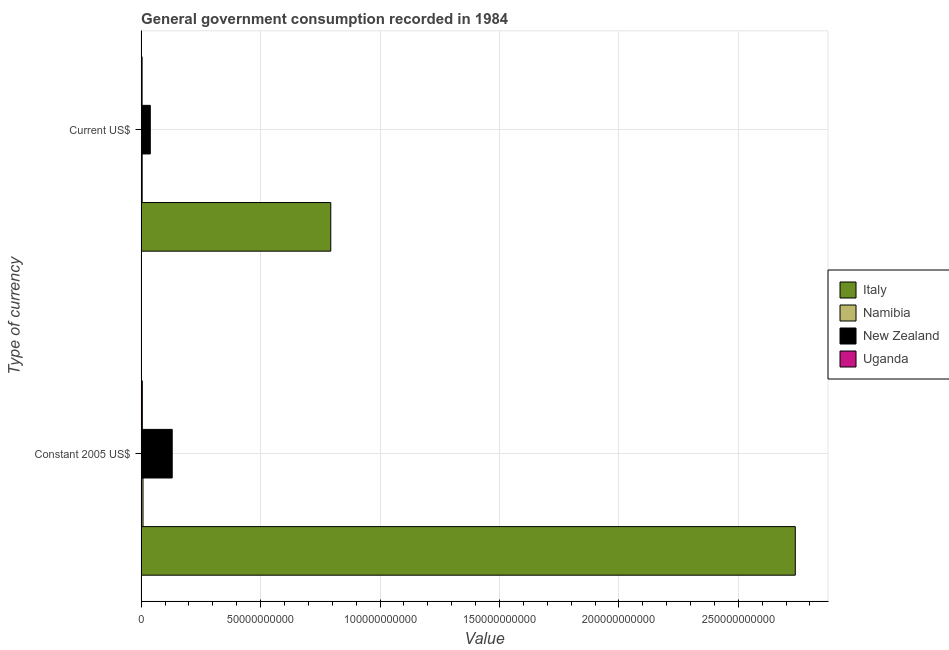How many different coloured bars are there?
Provide a short and direct response. 4. How many groups of bars are there?
Your response must be concise. 2. Are the number of bars per tick equal to the number of legend labels?
Provide a short and direct response. Yes. How many bars are there on the 1st tick from the bottom?
Offer a very short reply. 4. What is the label of the 1st group of bars from the top?
Provide a succinct answer. Current US$. What is the value consumed in current us$ in Namibia?
Give a very brief answer. 4.35e+08. Across all countries, what is the maximum value consumed in constant 2005 us$?
Ensure brevity in your answer.  2.74e+11. Across all countries, what is the minimum value consumed in current us$?
Provide a short and direct response. 3.97e+08. In which country was the value consumed in current us$ minimum?
Offer a very short reply. Uganda. What is the total value consumed in current us$ in the graph?
Provide a succinct answer. 8.40e+1. What is the difference between the value consumed in current us$ in Namibia and that in New Zealand?
Provide a succinct answer. -3.39e+09. What is the difference between the value consumed in constant 2005 us$ in Namibia and the value consumed in current us$ in Uganda?
Give a very brief answer. 3.85e+08. What is the average value consumed in constant 2005 us$ per country?
Offer a very short reply. 7.20e+1. What is the difference between the value consumed in constant 2005 us$ and value consumed in current us$ in Uganda?
Keep it short and to the point. 9.58e+07. What is the ratio of the value consumed in current us$ in New Zealand to that in Namibia?
Offer a very short reply. 8.79. Is the value consumed in current us$ in Uganda less than that in Italy?
Ensure brevity in your answer.  Yes. What does the 4th bar from the top in Current US$ represents?
Provide a succinct answer. Italy. How many bars are there?
Your answer should be compact. 8. What is the difference between two consecutive major ticks on the X-axis?
Ensure brevity in your answer.  5.00e+1. Where does the legend appear in the graph?
Offer a very short reply. Center right. How many legend labels are there?
Offer a terse response. 4. How are the legend labels stacked?
Your answer should be compact. Vertical. What is the title of the graph?
Your answer should be compact. General government consumption recorded in 1984. What is the label or title of the X-axis?
Your answer should be compact. Value. What is the label or title of the Y-axis?
Provide a short and direct response. Type of currency. What is the Value of Italy in Constant 2005 US$?
Your answer should be compact. 2.74e+11. What is the Value of Namibia in Constant 2005 US$?
Make the answer very short. 7.82e+08. What is the Value of New Zealand in Constant 2005 US$?
Keep it short and to the point. 1.30e+1. What is the Value of Uganda in Constant 2005 US$?
Make the answer very short. 4.93e+08. What is the Value in Italy in Current US$?
Ensure brevity in your answer.  7.94e+1. What is the Value of Namibia in Current US$?
Ensure brevity in your answer.  4.35e+08. What is the Value of New Zealand in Current US$?
Ensure brevity in your answer.  3.83e+09. What is the Value in Uganda in Current US$?
Give a very brief answer. 3.97e+08. Across all Type of currency, what is the maximum Value of Italy?
Your response must be concise. 2.74e+11. Across all Type of currency, what is the maximum Value of Namibia?
Ensure brevity in your answer.  7.82e+08. Across all Type of currency, what is the maximum Value in New Zealand?
Your response must be concise. 1.30e+1. Across all Type of currency, what is the maximum Value in Uganda?
Your answer should be very brief. 4.93e+08. Across all Type of currency, what is the minimum Value of Italy?
Your answer should be very brief. 7.94e+1. Across all Type of currency, what is the minimum Value of Namibia?
Provide a short and direct response. 4.35e+08. Across all Type of currency, what is the minimum Value of New Zealand?
Ensure brevity in your answer.  3.83e+09. Across all Type of currency, what is the minimum Value of Uganda?
Make the answer very short. 3.97e+08. What is the total Value in Italy in the graph?
Make the answer very short. 3.53e+11. What is the total Value in Namibia in the graph?
Provide a short and direct response. 1.22e+09. What is the total Value in New Zealand in the graph?
Your answer should be compact. 1.68e+1. What is the total Value in Uganda in the graph?
Offer a terse response. 8.90e+08. What is the difference between the Value of Italy in Constant 2005 US$ and that in Current US$?
Your response must be concise. 1.94e+11. What is the difference between the Value of Namibia in Constant 2005 US$ and that in Current US$?
Make the answer very short. 3.46e+08. What is the difference between the Value in New Zealand in Constant 2005 US$ and that in Current US$?
Provide a succinct answer. 9.18e+09. What is the difference between the Value in Uganda in Constant 2005 US$ and that in Current US$?
Give a very brief answer. 9.58e+07. What is the difference between the Value of Italy in Constant 2005 US$ and the Value of Namibia in Current US$?
Make the answer very short. 2.73e+11. What is the difference between the Value in Italy in Constant 2005 US$ and the Value in New Zealand in Current US$?
Ensure brevity in your answer.  2.70e+11. What is the difference between the Value in Italy in Constant 2005 US$ and the Value in Uganda in Current US$?
Provide a succinct answer. 2.73e+11. What is the difference between the Value in Namibia in Constant 2005 US$ and the Value in New Zealand in Current US$?
Your answer should be compact. -3.05e+09. What is the difference between the Value of Namibia in Constant 2005 US$ and the Value of Uganda in Current US$?
Offer a very short reply. 3.85e+08. What is the difference between the Value in New Zealand in Constant 2005 US$ and the Value in Uganda in Current US$?
Your answer should be compact. 1.26e+1. What is the average Value in Italy per Type of currency?
Ensure brevity in your answer.  1.77e+11. What is the average Value of Namibia per Type of currency?
Provide a short and direct response. 6.08e+08. What is the average Value in New Zealand per Type of currency?
Offer a terse response. 8.42e+09. What is the average Value of Uganda per Type of currency?
Keep it short and to the point. 4.45e+08. What is the difference between the Value of Italy and Value of Namibia in Constant 2005 US$?
Offer a terse response. 2.73e+11. What is the difference between the Value of Italy and Value of New Zealand in Constant 2005 US$?
Keep it short and to the point. 2.61e+11. What is the difference between the Value of Italy and Value of Uganda in Constant 2005 US$?
Provide a short and direct response. 2.73e+11. What is the difference between the Value of Namibia and Value of New Zealand in Constant 2005 US$?
Keep it short and to the point. -1.22e+1. What is the difference between the Value in Namibia and Value in Uganda in Constant 2005 US$?
Ensure brevity in your answer.  2.89e+08. What is the difference between the Value of New Zealand and Value of Uganda in Constant 2005 US$?
Make the answer very short. 1.25e+1. What is the difference between the Value of Italy and Value of Namibia in Current US$?
Give a very brief answer. 7.89e+1. What is the difference between the Value in Italy and Value in New Zealand in Current US$?
Offer a terse response. 7.56e+1. What is the difference between the Value of Italy and Value of Uganda in Current US$?
Your answer should be very brief. 7.90e+1. What is the difference between the Value in Namibia and Value in New Zealand in Current US$?
Your response must be concise. -3.39e+09. What is the difference between the Value in Namibia and Value in Uganda in Current US$?
Keep it short and to the point. 3.85e+07. What is the difference between the Value of New Zealand and Value of Uganda in Current US$?
Give a very brief answer. 3.43e+09. What is the ratio of the Value of Italy in Constant 2005 US$ to that in Current US$?
Ensure brevity in your answer.  3.45. What is the ratio of the Value in Namibia in Constant 2005 US$ to that in Current US$?
Your answer should be compact. 1.8. What is the ratio of the Value in New Zealand in Constant 2005 US$ to that in Current US$?
Provide a succinct answer. 3.4. What is the ratio of the Value in Uganda in Constant 2005 US$ to that in Current US$?
Provide a succinct answer. 1.24. What is the difference between the highest and the second highest Value of Italy?
Your answer should be very brief. 1.94e+11. What is the difference between the highest and the second highest Value in Namibia?
Offer a very short reply. 3.46e+08. What is the difference between the highest and the second highest Value in New Zealand?
Keep it short and to the point. 9.18e+09. What is the difference between the highest and the second highest Value of Uganda?
Your answer should be compact. 9.58e+07. What is the difference between the highest and the lowest Value of Italy?
Offer a very short reply. 1.94e+11. What is the difference between the highest and the lowest Value of Namibia?
Provide a succinct answer. 3.46e+08. What is the difference between the highest and the lowest Value in New Zealand?
Provide a short and direct response. 9.18e+09. What is the difference between the highest and the lowest Value in Uganda?
Your response must be concise. 9.58e+07. 